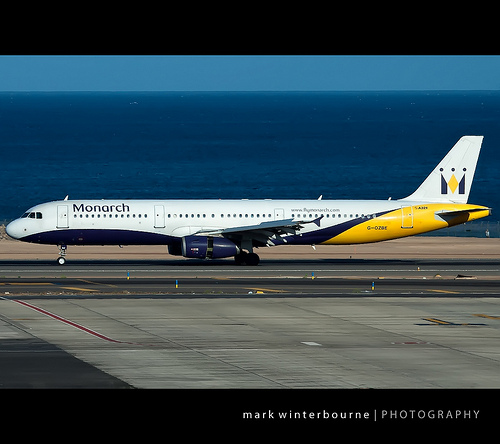Please provide a short description for this region: [0.48, 0.87, 0.97, 0.89]. White text located at the bottom of the image, possibly related to the watermark or photo credit. 